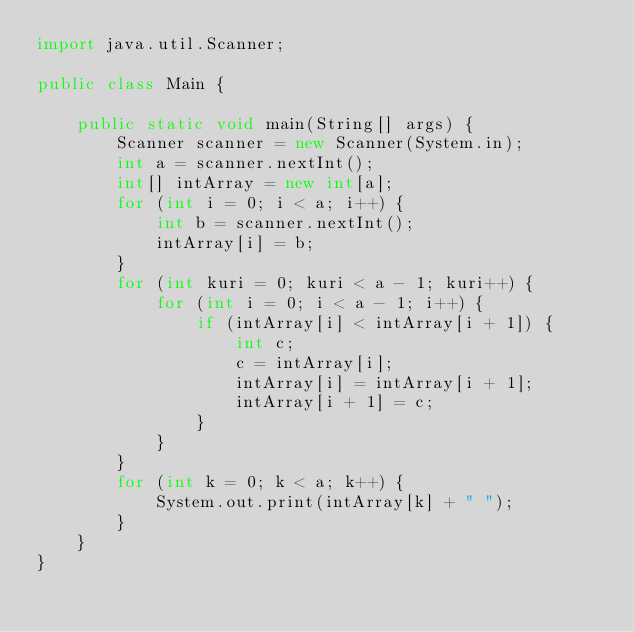<code> <loc_0><loc_0><loc_500><loc_500><_Java_>import java.util.Scanner;

public class Main {

    public static void main(String[] args) {
        Scanner scanner = new Scanner(System.in);
        int a = scanner.nextInt();
        int[] intArray = new int[a];
        for (int i = 0; i < a; i++) {
            int b = scanner.nextInt();
            intArray[i] = b;
        }
        for (int kuri = 0; kuri < a - 1; kuri++) {
            for (int i = 0; i < a - 1; i++) {
                if (intArray[i] < intArray[i + 1]) {
                    int c;
                    c = intArray[i];
                    intArray[i] = intArray[i + 1];
                    intArray[i + 1] = c;
                }
            }
        }
        for (int k = 0; k < a; k++) {
            System.out.print(intArray[k] + " ");
        }
    }
}</code> 